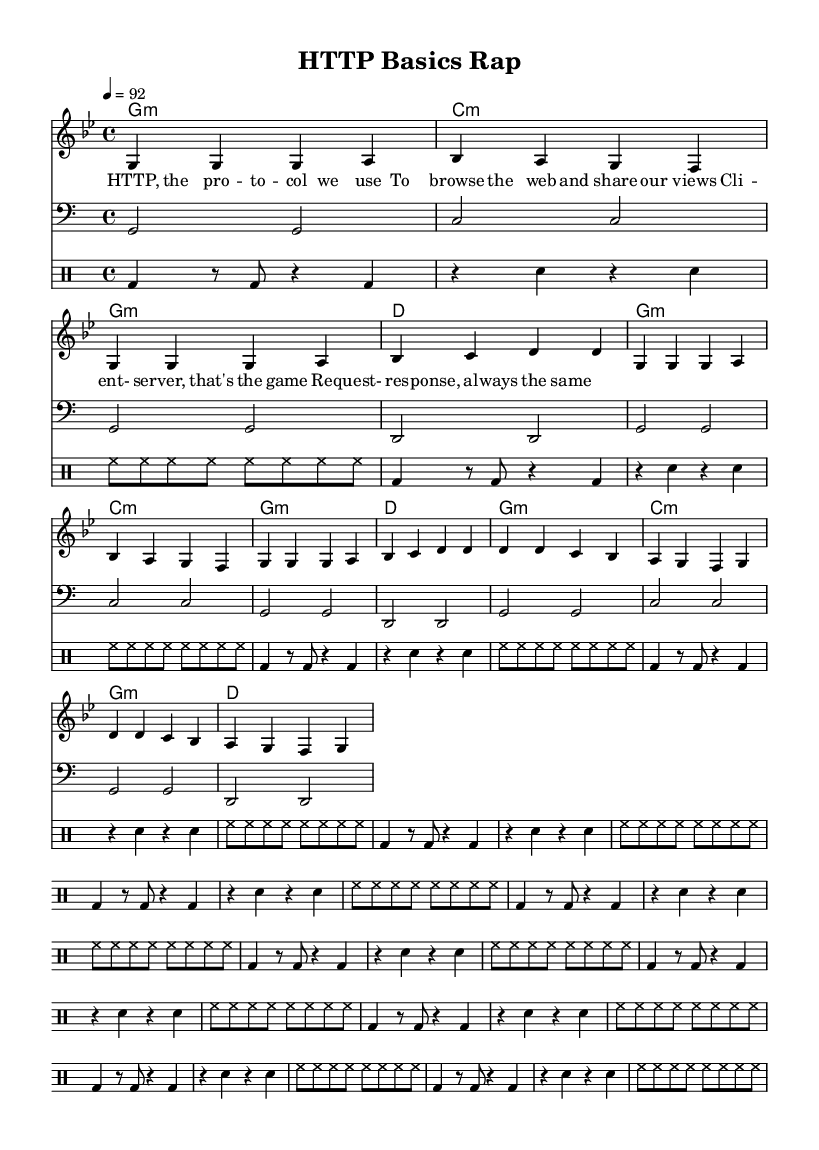What is the key signature of this music? The key signature is G minor, indicated by the presence of two flats (B-flat and E-flat) in the scale of G.
Answer: G minor What is the time signature of this music? The time signature is 4/4, which means there are four beats per measure and the quarter note gets one beat, as indicated at the beginning of the score.
Answer: 4/4 What is the tempo marking for this piece? The tempo marking is 92, signifying a speed of 92 beats per minute, indicated at the start of the score.
Answer: 92 How many measures are in the melody? The melody contains twelve measures as counted through the notes and bars in the melody section.
Answer: 12 What type of rhyme scheme is present in the lyrics? The lyrics follow an AABB rhyme scheme where the first two lines rhyme with each other, and the next two lines also rhyme with each other, confirmed by the ending words of each line in the text.
Answer: AABB What is the primary musical element used in the rhythm? The primary element used in the rhythm is the combination of syncopation in the drum patterns, which provides an engaging beat aligning with the rap style of the song.
Answer: Syncopation 